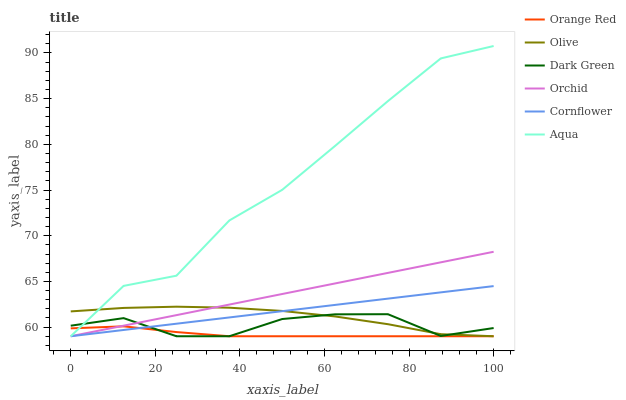Does Orange Red have the minimum area under the curve?
Answer yes or no. Yes. Does Aqua have the maximum area under the curve?
Answer yes or no. Yes. Does Olive have the minimum area under the curve?
Answer yes or no. No. Does Olive have the maximum area under the curve?
Answer yes or no. No. Is Cornflower the smoothest?
Answer yes or no. Yes. Is Aqua the roughest?
Answer yes or no. Yes. Is Olive the smoothest?
Answer yes or no. No. Is Olive the roughest?
Answer yes or no. No. Does Cornflower have the lowest value?
Answer yes or no. Yes. Does Aqua have the highest value?
Answer yes or no. Yes. Does Olive have the highest value?
Answer yes or no. No. Does Orange Red intersect Dark Green?
Answer yes or no. Yes. Is Orange Red less than Dark Green?
Answer yes or no. No. Is Orange Red greater than Dark Green?
Answer yes or no. No. 